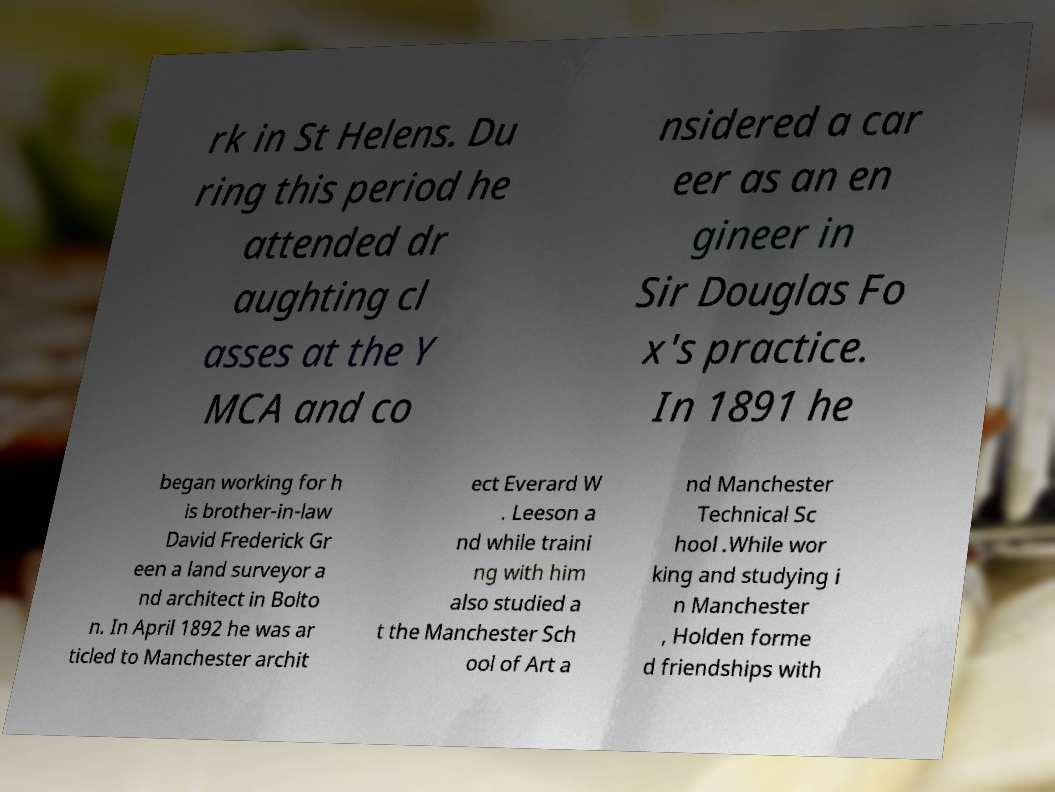Can you accurately transcribe the text from the provided image for me? rk in St Helens. Du ring this period he attended dr aughting cl asses at the Y MCA and co nsidered a car eer as an en gineer in Sir Douglas Fo x's practice. In 1891 he began working for h is brother-in-law David Frederick Gr een a land surveyor a nd architect in Bolto n. In April 1892 he was ar ticled to Manchester archit ect Everard W . Leeson a nd while traini ng with him also studied a t the Manchester Sch ool of Art a nd Manchester Technical Sc hool .While wor king and studying i n Manchester , Holden forme d friendships with 